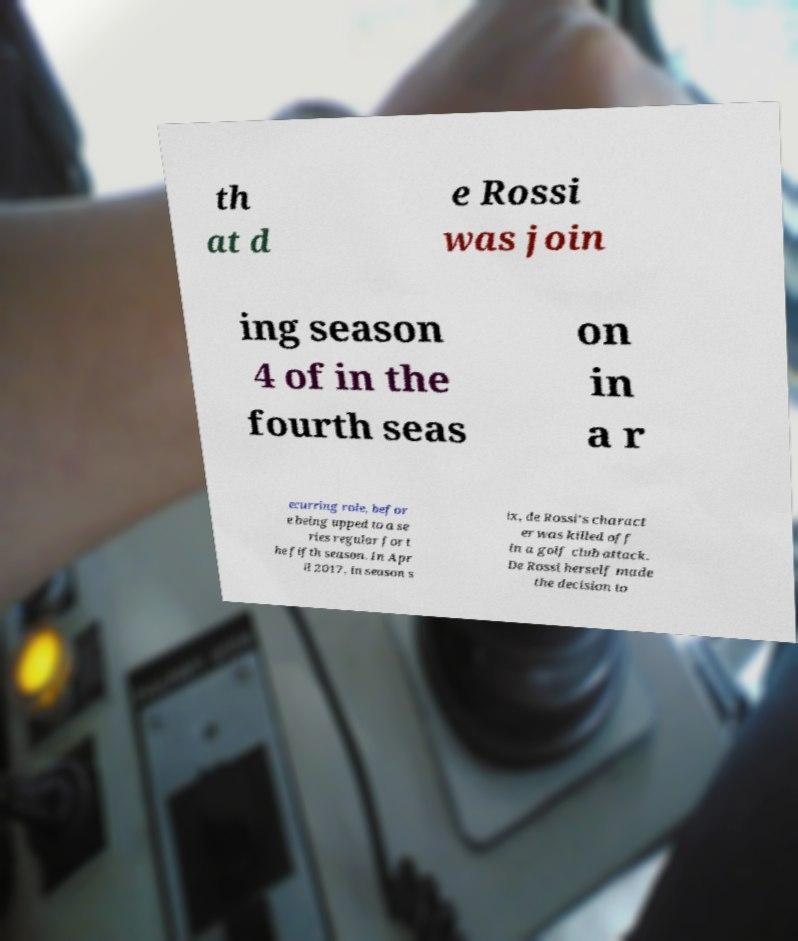I need the written content from this picture converted into text. Can you do that? th at d e Rossi was join ing season 4 of in the fourth seas on in a r ecurring role, befor e being upped to a se ries regular for t he fifth season. In Apr il 2017, in season s ix, de Rossi's charact er was killed off in a golf club attack. De Rossi herself made the decision to 